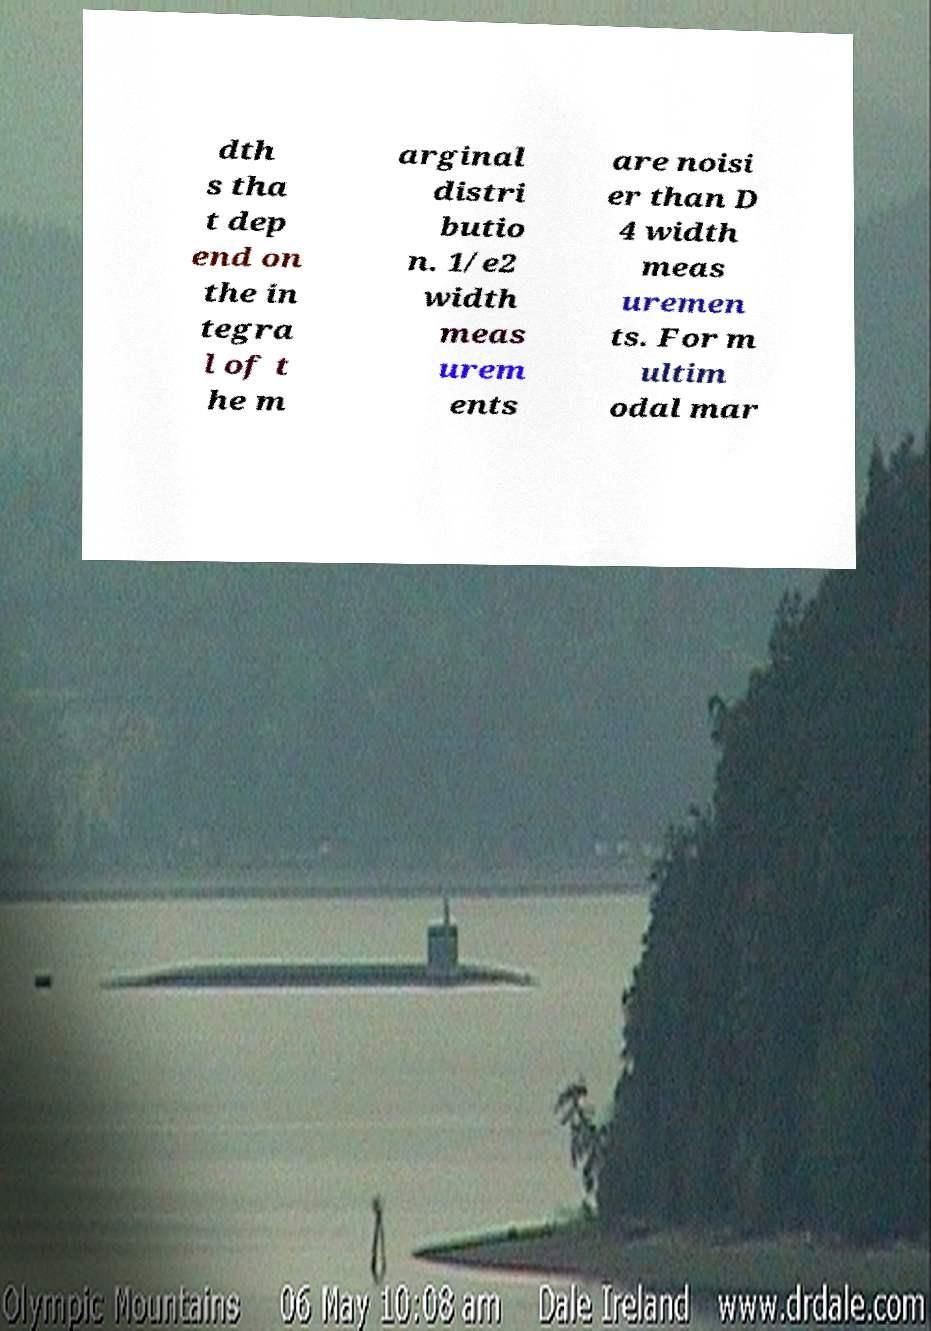There's text embedded in this image that I need extracted. Can you transcribe it verbatim? dth s tha t dep end on the in tegra l of t he m arginal distri butio n. 1/e2 width meas urem ents are noisi er than D 4 width meas uremen ts. For m ultim odal mar 